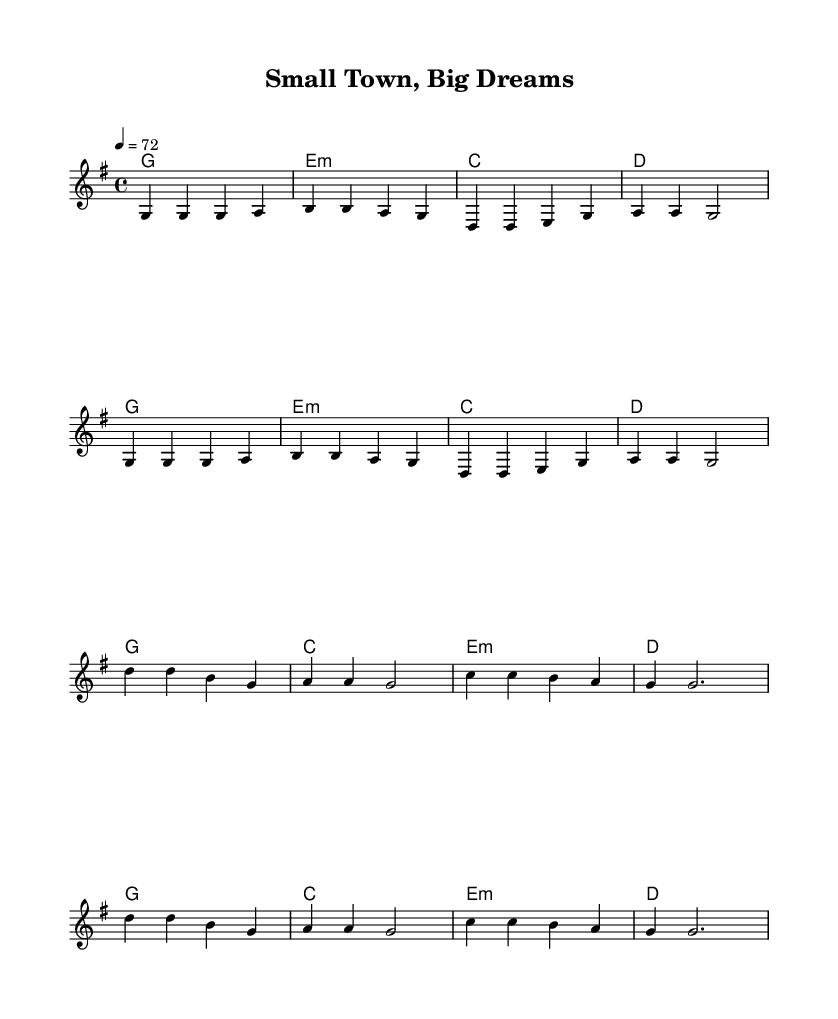What is the key signature of this music? The key signature is G major, which includes one sharp (F#) in the scale. This is identified by the presence of the sharp at the beginning of the staff.
Answer: G major What is the time signature of this music? The time signature is 4/4, indicated at the beginning of the score. It shows that there are four beats in each measure and the quarter note receives one beat.
Answer: 4/4 What is the tempo marking indicated in the sheet music? The tempo marking shows the piece should be played at a speed of 72 beats per minute, as noted under the tempo instruction. This gives guidance on how fast the piece should be performed.
Answer: 72 How many measures are in the verse section? By counting the distinct line segments that contain the musical notes in the verse, we find that there are eight measures present in the verse section.
Answer: Eight What is the first chord of the chorus? The first chord of the chorus is D major, which is represented at the start of the chorus section. We can see this from the chord symbols placed above the melody line.
Answer: D major In terms of lyrics, what is the main theme of the chorus? The main theme of the chorus revolves around empowerment and breaking through challenges, highlighted in lyrics mentioning "small town, big dreams." This indicates a focus on overcoming barriers and pursuing aspirations.
Answer: Empowerment How does the structure of this song reflect typical Country Rock features? The song features a verse-chorus format, which is common in Country Rock. It combines storytelling in the verses with memorable and anthemic choruses, particularly highlighting themes of resilience and unity, typical of the genre's appeal.
Answer: Verse-chorus format 